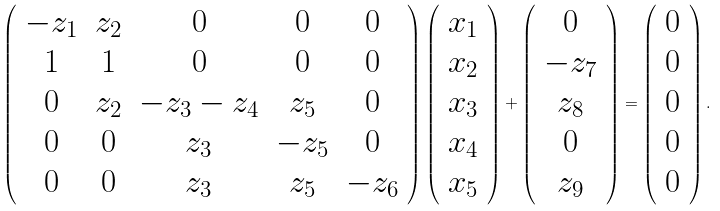<formula> <loc_0><loc_0><loc_500><loc_500>\left ( \begin{array} { c c c c c } - z _ { 1 } & z _ { 2 } & 0 & 0 & 0 \\ 1 & 1 & 0 & 0 & 0 \\ 0 & z _ { 2 } & - z _ { 3 } - z _ { 4 } & z _ { 5 } & 0 \\ 0 & 0 & z _ { 3 } & - z _ { 5 } & 0 \\ 0 & 0 & z _ { 3 } & z _ { 5 } & - z _ { 6 } \end{array} \right ) \left ( \begin{array} { c } x _ { 1 } \\ x _ { 2 } \\ x _ { 3 } \\ x _ { 4 } \\ x _ { 5 } \end{array} \right ) + \left ( \begin{array} { c } 0 \\ - z _ { 7 } \\ z _ { 8 } \\ 0 \\ z _ { 9 } \end{array} \right ) = \left ( \begin{array} { c } 0 \\ 0 \\ 0 \\ 0 \\ 0 \end{array} \right ) .</formula> 